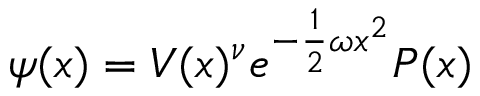Convert formula to latex. <formula><loc_0><loc_0><loc_500><loc_500>\psi ( x ) = V ( x ) ^ { \nu } e ^ { - \frac { 1 } { 2 } \omega x ^ { 2 } } P ( x )</formula> 